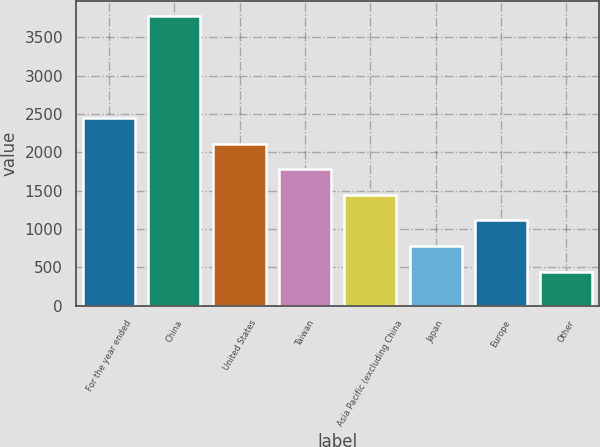<chart> <loc_0><loc_0><loc_500><loc_500><bar_chart><fcel>For the year ended<fcel>China<fcel>United States<fcel>Taiwan<fcel>Asia Pacific (excluding China<fcel>Japan<fcel>Europe<fcel>Other<nl><fcel>2447<fcel>3783<fcel>2113<fcel>1779<fcel>1445<fcel>777<fcel>1111<fcel>443<nl></chart> 